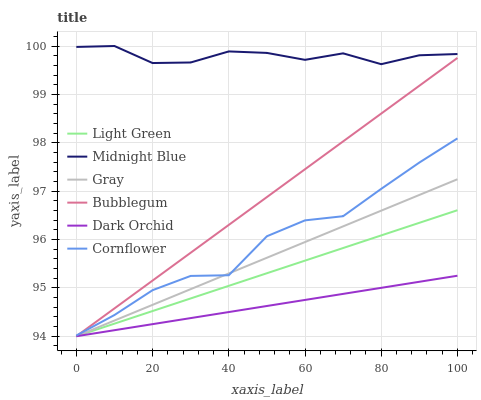Does Dark Orchid have the minimum area under the curve?
Answer yes or no. Yes. Does Midnight Blue have the maximum area under the curve?
Answer yes or no. Yes. Does Cornflower have the minimum area under the curve?
Answer yes or no. No. Does Cornflower have the maximum area under the curve?
Answer yes or no. No. Is Light Green the smoothest?
Answer yes or no. Yes. Is Cornflower the roughest?
Answer yes or no. Yes. Is Midnight Blue the smoothest?
Answer yes or no. No. Is Midnight Blue the roughest?
Answer yes or no. No. Does Gray have the lowest value?
Answer yes or no. Yes. Does Cornflower have the lowest value?
Answer yes or no. No. Does Midnight Blue have the highest value?
Answer yes or no. Yes. Does Cornflower have the highest value?
Answer yes or no. No. Is Bubblegum less than Midnight Blue?
Answer yes or no. Yes. Is Midnight Blue greater than Dark Orchid?
Answer yes or no. Yes. Does Light Green intersect Gray?
Answer yes or no. Yes. Is Light Green less than Gray?
Answer yes or no. No. Is Light Green greater than Gray?
Answer yes or no. No. Does Bubblegum intersect Midnight Blue?
Answer yes or no. No. 